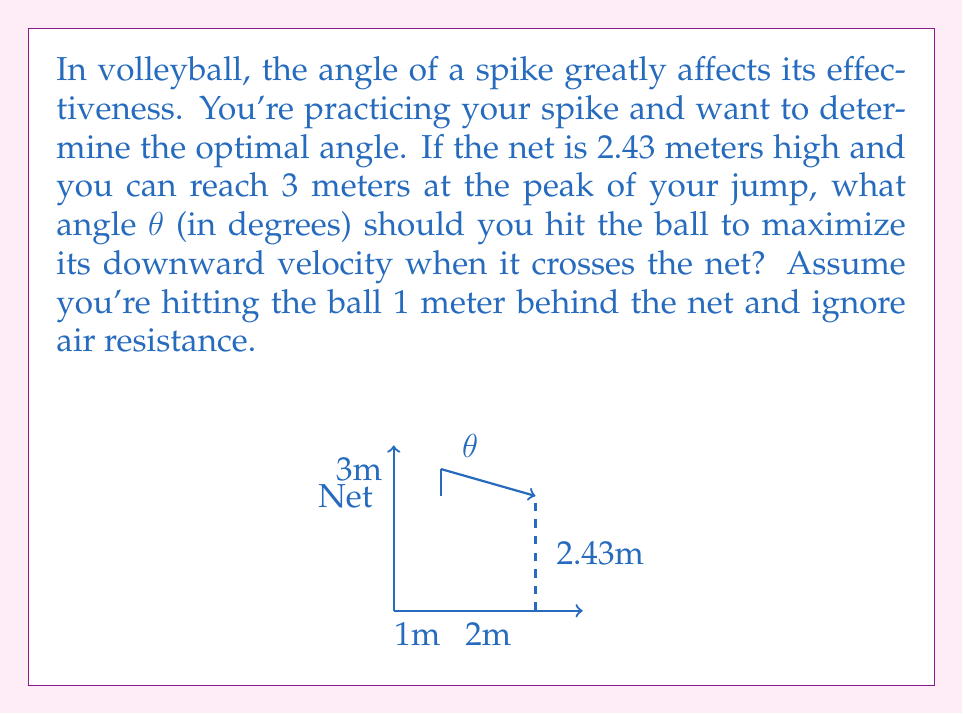Could you help me with this problem? Let's approach this step-by-step:

1) First, we need to identify the triangle formed by the spike path, the net, and the horizontal distance to the net.

2) We can see that this forms a right triangle, where:
   - The hypotenuse is the spike path
   - The opposite side is the difference in height (3m - 2.43m = 0.57m)
   - The adjacent side is the horizontal distance (1m + 2m = 3m)

3) To maximize downward velocity, we want to maximize the angle θ.

4) We can use the tangent function to find this angle:

   $$\tan(\theta) = \frac{\text{opposite}}{\text{adjacent}} = \frac{0.57}{3}$$

5) To solve for θ, we use the inverse tangent (arctan or $\tan^{-1}$):

   $$\theta = \tan^{-1}(\frac{0.57}{3})$$

6) Using a calculator or computer:

   $$\theta \approx 10.75^\circ$$

7) Round to the nearest degree:

   $$\theta \approx 11^\circ$$

Therefore, to maximize the downward velocity of the spike as it crosses the net, you should hit the ball at an angle of approximately 11° from the horizontal.
Answer: $11^\circ$ 